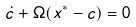Convert formula to latex. <formula><loc_0><loc_0><loc_500><loc_500>\dot { c } + \Omega ( x ^ { * } - c ) = 0</formula> 